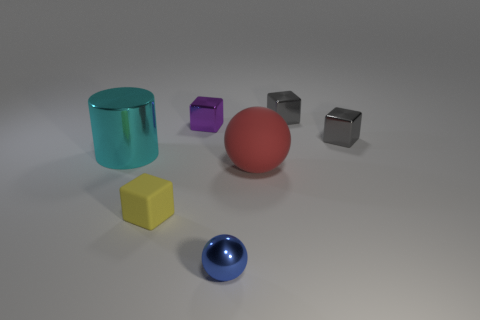What number of other objects are the same shape as the purple object?
Your answer should be very brief. 3. Are there more tiny cubes in front of the matte cube than small purple metallic cubes that are right of the shiny sphere?
Ensure brevity in your answer.  No. There is a ball that is behind the shiny ball; is its size the same as the metallic block that is on the left side of the blue metal sphere?
Ensure brevity in your answer.  No. There is a small blue object; what shape is it?
Offer a terse response. Sphere. What color is the tiny ball that is the same material as the cyan cylinder?
Provide a succinct answer. Blue. Is the large red ball made of the same material as the sphere that is to the left of the big matte sphere?
Make the answer very short. No. What is the color of the tiny sphere?
Offer a terse response. Blue. The purple block that is the same material as the small blue thing is what size?
Keep it short and to the point. Small. How many shiny spheres are behind the large thing in front of the thing left of the tiny yellow thing?
Give a very brief answer. 0. Does the rubber sphere have the same color as the shiny thing that is to the left of the tiny yellow block?
Provide a succinct answer. No. 